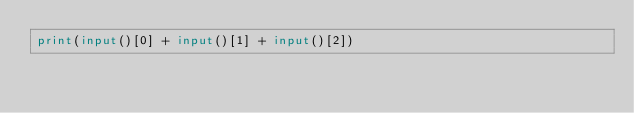Convert code to text. <code><loc_0><loc_0><loc_500><loc_500><_Python_>print(input()[0] + input()[1] + input()[2])</code> 